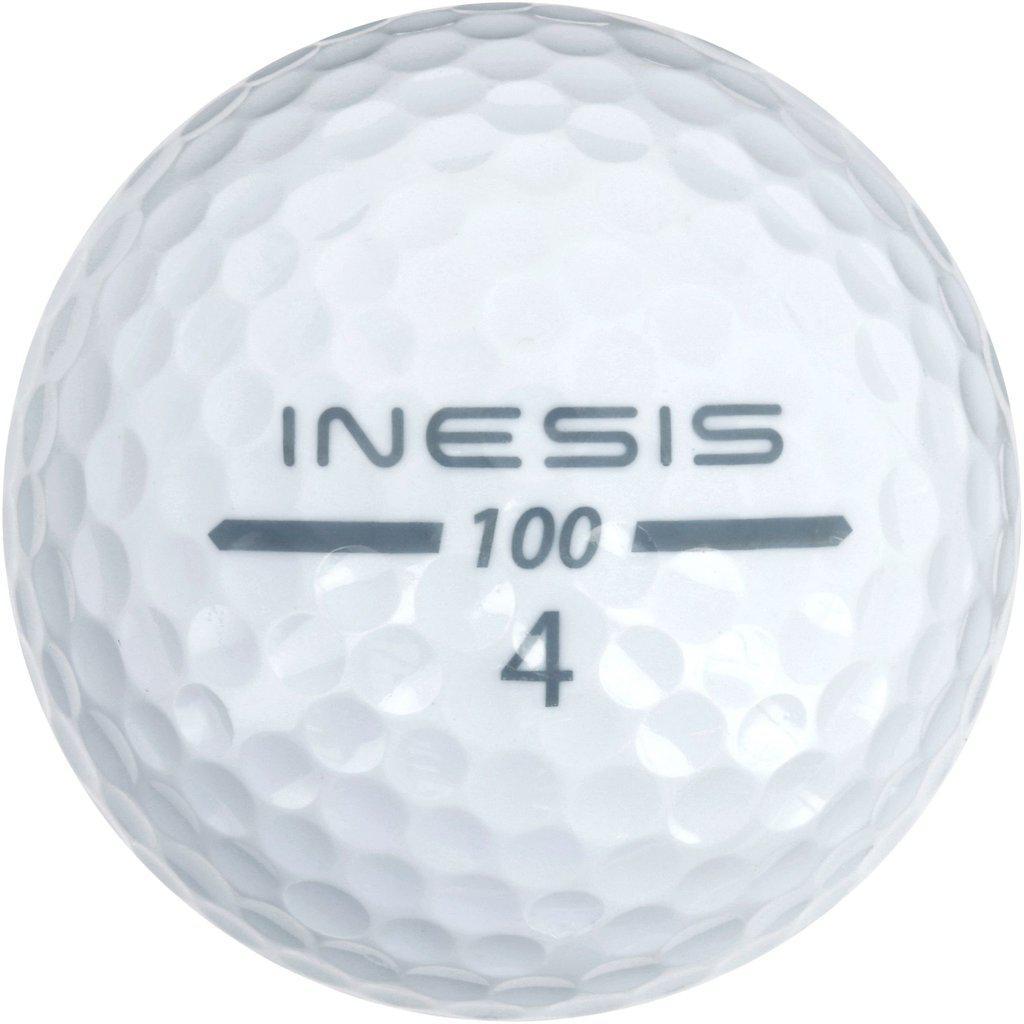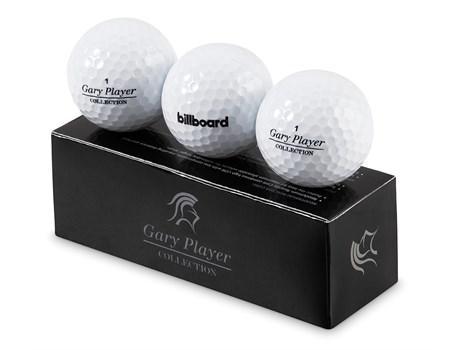The first image is the image on the left, the second image is the image on the right. Given the left and right images, does the statement "The left and right image contains a total of four golf balls." hold true? Answer yes or no. Yes. The first image is the image on the left, the second image is the image on the right. For the images displayed, is the sentence "There's three golf balls in one image and one in the other image." factually correct? Answer yes or no. Yes. 